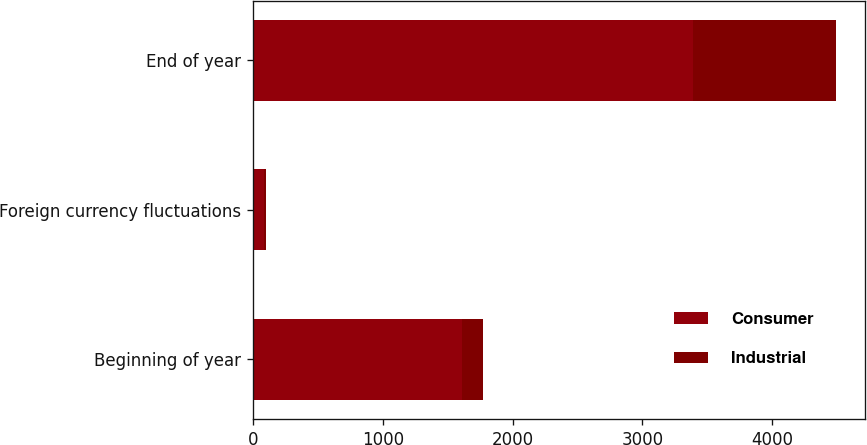<chart> <loc_0><loc_0><loc_500><loc_500><stacked_bar_chart><ecel><fcel>Beginning of year<fcel>Foreign currency fluctuations<fcel>End of year<nl><fcel>Consumer<fcel>1608.3<fcel>86.7<fcel>3385.4<nl><fcel>Industrial<fcel>163.1<fcel>12.3<fcel>1104.7<nl></chart> 